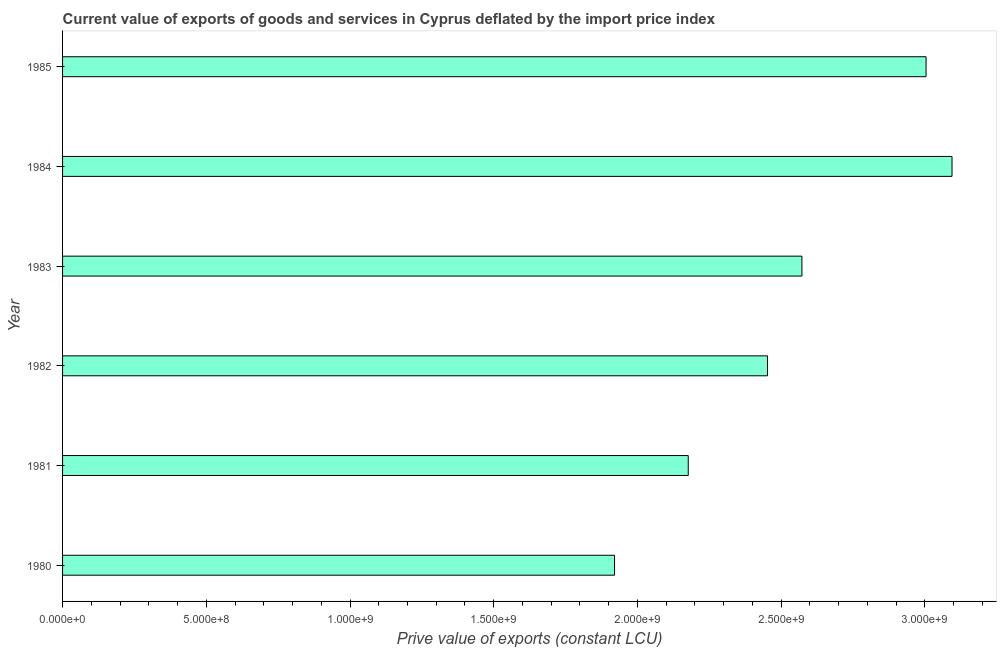Does the graph contain any zero values?
Offer a very short reply. No. What is the title of the graph?
Provide a succinct answer. Current value of exports of goods and services in Cyprus deflated by the import price index. What is the label or title of the X-axis?
Your response must be concise. Prive value of exports (constant LCU). What is the label or title of the Y-axis?
Offer a very short reply. Year. What is the price value of exports in 1983?
Your answer should be compact. 2.57e+09. Across all years, what is the maximum price value of exports?
Your answer should be very brief. 3.09e+09. Across all years, what is the minimum price value of exports?
Your response must be concise. 1.92e+09. In which year was the price value of exports maximum?
Ensure brevity in your answer.  1984. In which year was the price value of exports minimum?
Your answer should be very brief. 1980. What is the sum of the price value of exports?
Your response must be concise. 1.52e+1. What is the difference between the price value of exports in 1980 and 1984?
Your answer should be compact. -1.17e+09. What is the average price value of exports per year?
Provide a succinct answer. 2.54e+09. What is the median price value of exports?
Ensure brevity in your answer.  2.51e+09. Do a majority of the years between 1984 and 1980 (inclusive) have price value of exports greater than 2800000000 LCU?
Offer a very short reply. Yes. What is the ratio of the price value of exports in 1980 to that in 1981?
Give a very brief answer. 0.88. Is the price value of exports in 1981 less than that in 1982?
Your answer should be very brief. Yes. Is the difference between the price value of exports in 1984 and 1985 greater than the difference between any two years?
Give a very brief answer. No. What is the difference between the highest and the second highest price value of exports?
Your answer should be very brief. 9.03e+07. What is the difference between the highest and the lowest price value of exports?
Offer a terse response. 1.17e+09. In how many years, is the price value of exports greater than the average price value of exports taken over all years?
Provide a succinct answer. 3. How many bars are there?
Your response must be concise. 6. Are all the bars in the graph horizontal?
Offer a very short reply. Yes. How many years are there in the graph?
Give a very brief answer. 6. What is the difference between two consecutive major ticks on the X-axis?
Make the answer very short. 5.00e+08. Are the values on the major ticks of X-axis written in scientific E-notation?
Provide a short and direct response. Yes. What is the Prive value of exports (constant LCU) in 1980?
Provide a short and direct response. 1.92e+09. What is the Prive value of exports (constant LCU) in 1981?
Offer a very short reply. 2.18e+09. What is the Prive value of exports (constant LCU) of 1982?
Your response must be concise. 2.45e+09. What is the Prive value of exports (constant LCU) of 1983?
Provide a short and direct response. 2.57e+09. What is the Prive value of exports (constant LCU) of 1984?
Your answer should be very brief. 3.09e+09. What is the Prive value of exports (constant LCU) in 1985?
Your response must be concise. 3.00e+09. What is the difference between the Prive value of exports (constant LCU) in 1980 and 1981?
Offer a terse response. -2.56e+08. What is the difference between the Prive value of exports (constant LCU) in 1980 and 1982?
Keep it short and to the point. -5.32e+08. What is the difference between the Prive value of exports (constant LCU) in 1980 and 1983?
Offer a very short reply. -6.52e+08. What is the difference between the Prive value of exports (constant LCU) in 1980 and 1984?
Provide a short and direct response. -1.17e+09. What is the difference between the Prive value of exports (constant LCU) in 1980 and 1985?
Your response must be concise. -1.08e+09. What is the difference between the Prive value of exports (constant LCU) in 1981 and 1982?
Provide a short and direct response. -2.76e+08. What is the difference between the Prive value of exports (constant LCU) in 1981 and 1983?
Offer a terse response. -3.95e+08. What is the difference between the Prive value of exports (constant LCU) in 1981 and 1984?
Keep it short and to the point. -9.18e+08. What is the difference between the Prive value of exports (constant LCU) in 1981 and 1985?
Give a very brief answer. -8.27e+08. What is the difference between the Prive value of exports (constant LCU) in 1982 and 1983?
Make the answer very short. -1.20e+08. What is the difference between the Prive value of exports (constant LCU) in 1982 and 1984?
Provide a succinct answer. -6.42e+08. What is the difference between the Prive value of exports (constant LCU) in 1982 and 1985?
Offer a terse response. -5.52e+08. What is the difference between the Prive value of exports (constant LCU) in 1983 and 1984?
Ensure brevity in your answer.  -5.22e+08. What is the difference between the Prive value of exports (constant LCU) in 1983 and 1985?
Your answer should be compact. -4.32e+08. What is the difference between the Prive value of exports (constant LCU) in 1984 and 1985?
Give a very brief answer. 9.03e+07. What is the ratio of the Prive value of exports (constant LCU) in 1980 to that in 1981?
Give a very brief answer. 0.88. What is the ratio of the Prive value of exports (constant LCU) in 1980 to that in 1982?
Keep it short and to the point. 0.78. What is the ratio of the Prive value of exports (constant LCU) in 1980 to that in 1983?
Ensure brevity in your answer.  0.75. What is the ratio of the Prive value of exports (constant LCU) in 1980 to that in 1984?
Give a very brief answer. 0.62. What is the ratio of the Prive value of exports (constant LCU) in 1980 to that in 1985?
Keep it short and to the point. 0.64. What is the ratio of the Prive value of exports (constant LCU) in 1981 to that in 1982?
Offer a very short reply. 0.89. What is the ratio of the Prive value of exports (constant LCU) in 1981 to that in 1983?
Your answer should be compact. 0.85. What is the ratio of the Prive value of exports (constant LCU) in 1981 to that in 1984?
Offer a terse response. 0.7. What is the ratio of the Prive value of exports (constant LCU) in 1981 to that in 1985?
Make the answer very short. 0.72. What is the ratio of the Prive value of exports (constant LCU) in 1982 to that in 1983?
Ensure brevity in your answer.  0.95. What is the ratio of the Prive value of exports (constant LCU) in 1982 to that in 1984?
Offer a very short reply. 0.79. What is the ratio of the Prive value of exports (constant LCU) in 1982 to that in 1985?
Provide a succinct answer. 0.82. What is the ratio of the Prive value of exports (constant LCU) in 1983 to that in 1984?
Your response must be concise. 0.83. What is the ratio of the Prive value of exports (constant LCU) in 1983 to that in 1985?
Keep it short and to the point. 0.86. 